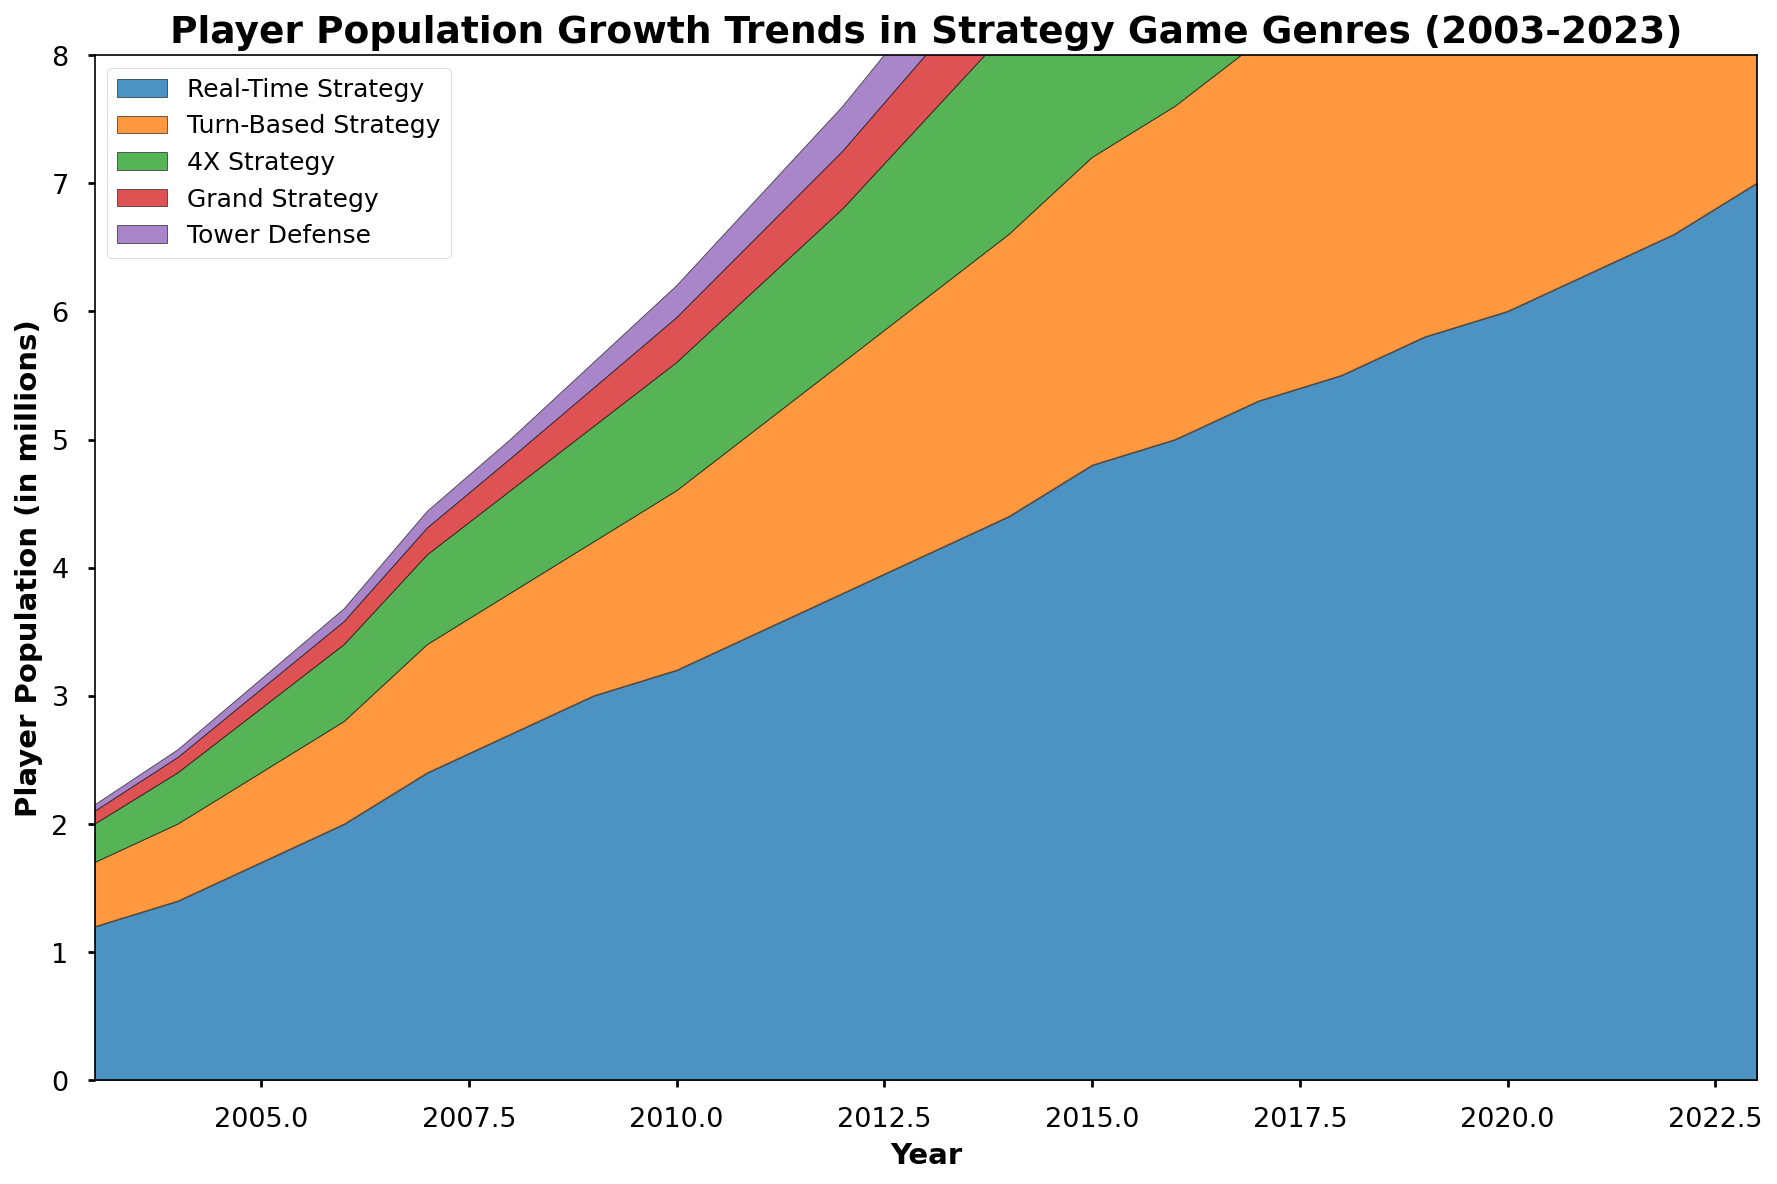Which strategy game genre had the highest player population growth in 2023? Look at the topmost section of the chart in 2023, which is the light blue area representing Real-Time Strategy. This section is the largest compared to others.
Answer: Real-Time Strategy Which game genre saw the least growth in player population in the year 2020 compared to 2010? Compare the size of each colored section for 2010 and 2020. The smallest increase is in the Tower Defense genre, which shows a smaller growth compared to other segments.
Answer: Tower Defense What's the total player population across all genres in 2015? Sum the heights of all the colored sections above the year 2015. Adding 4.8 (Real-Time Strategy) + 2.4 (Turn-Based Strategy) + 1.8 (4X Strategy) + 0.6 (Grand Strategy) + 0.5 (Tower Defense) gives 10.1 million.
Answer: 10.1 million Which two genres had an equal player population in any year? Look at each year's values. In 2004, Turn-Based Strategy (0.6) and 4X Strategy (0.4) are not equal initially, but in 2023, comparing the figures, none of the sections are visually equal. Thus, there isn't a year where they are equal.
Answer: None What is the difference in player population between Real-Time Strategy and Grand Strategy in 2013? Refer to the chart in 2013. Real-Time Strategy has a height of 4.1, and Grand Strategy has a height of 0.5. The difference is 4.1 - 0.5 = 3.6 million.
Answer: 3.6 million By how much did the player population in Turn-Based Strategy increase from 2005 to 2015? Check the height of the Turn-Based Strategy layer in 2005 and 2015. It increased from 0.7 to 2.4. The difference is 2.4 - 0.7 = 1.7 million.
Answer: 1.7 million Which genre showed a constant and significant rise throughout the 20 years? Observe the overall trends for each genre on the chart. Real-Time Strategy shows a consistent slope upward with no declines, indicating constant and significant growth.
Answer: Real-Time Strategy What's the average player population of 4X Strategy from 2018 to 2023? Find the values for 4X Strategy from 2018-2023: (2.4, 2.6, 2.8, 3.0, 3.2, 3.4), sum them to get 16.4. Divide by 6 (the number of years) which gives 16.4 / 6 ≈ 2.73 million.
Answer: 2.73 million Compare the growth rates of Grand Strategy and Tower Defense from 2003 to 2013. Which grew faster? In 2003, Grand Strategy is 0.1, Tower Defense is 0.05. In 2013, Grand Strategy is 0.5, Tower Defense is 0.4. Growth for Grand Strategy is 0.5-0.1=0.4; for Tower Defense, 0.4-0.05=0.35. Therefore, Grand Strategy grew faster.
Answer: Grand Strategy 